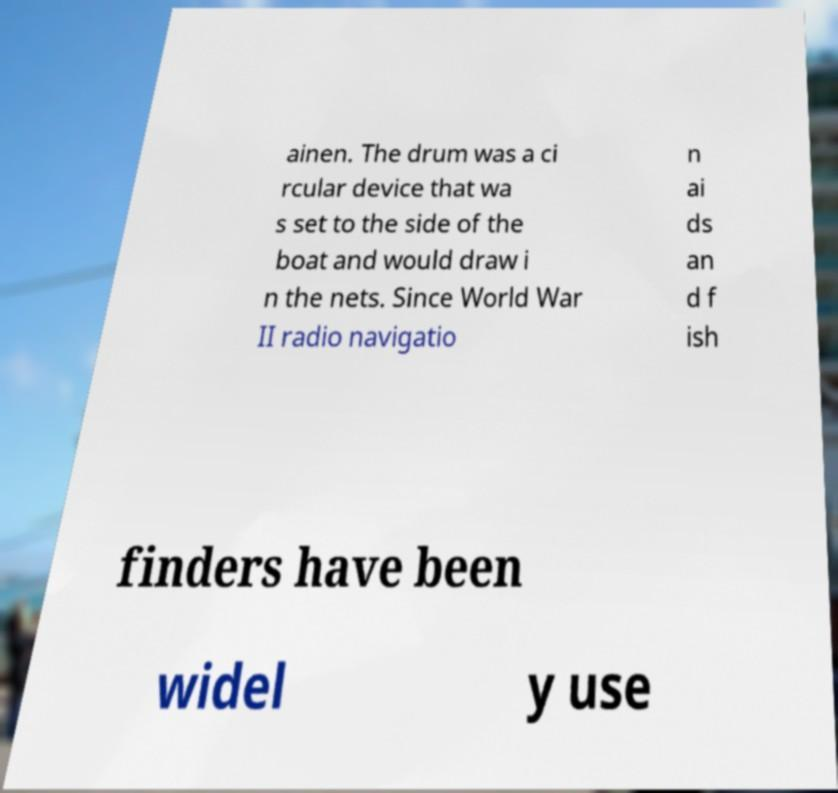Can you accurately transcribe the text from the provided image for me? ainen. The drum was a ci rcular device that wa s set to the side of the boat and would draw i n the nets. Since World War II radio navigatio n ai ds an d f ish finders have been widel y use 